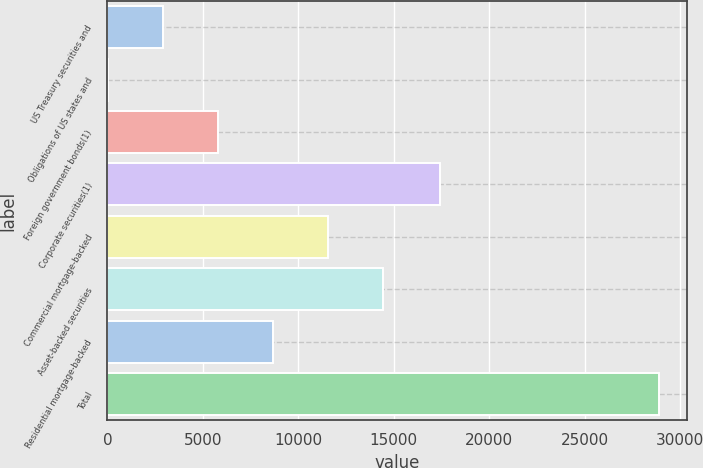Convert chart. <chart><loc_0><loc_0><loc_500><loc_500><bar_chart><fcel>US Treasury securities and<fcel>Obligations of US states and<fcel>Foreign government bonds(1)<fcel>Corporate securities(1)<fcel>Commercial mortgage-backed<fcel>Asset-backed securities<fcel>Residential mortgage-backed<fcel>Total<nl><fcel>2895.1<fcel>7<fcel>5783.2<fcel>17397<fcel>11559.4<fcel>14447.5<fcel>8671.3<fcel>28888<nl></chart> 